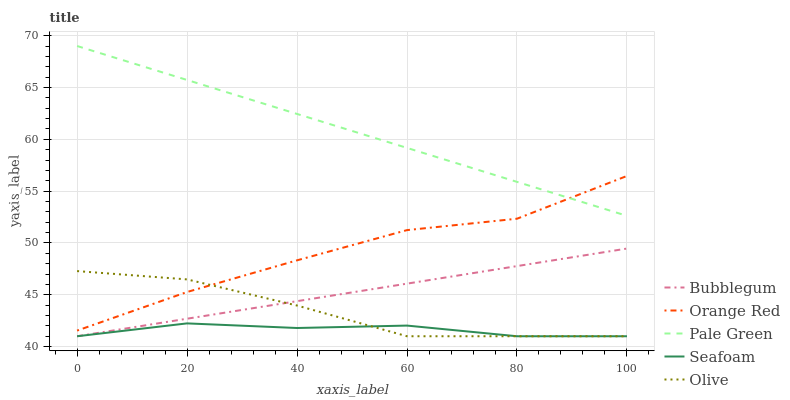Does Seafoam have the minimum area under the curve?
Answer yes or no. Yes. Does Pale Green have the maximum area under the curve?
Answer yes or no. Yes. Does Orange Red have the minimum area under the curve?
Answer yes or no. No. Does Orange Red have the maximum area under the curve?
Answer yes or no. No. Is Bubblegum the smoothest?
Answer yes or no. Yes. Is Orange Red the roughest?
Answer yes or no. Yes. Is Pale Green the smoothest?
Answer yes or no. No. Is Pale Green the roughest?
Answer yes or no. No. Does Olive have the lowest value?
Answer yes or no. Yes. Does Orange Red have the lowest value?
Answer yes or no. No. Does Pale Green have the highest value?
Answer yes or no. Yes. Does Orange Red have the highest value?
Answer yes or no. No. Is Seafoam less than Orange Red?
Answer yes or no. Yes. Is Orange Red greater than Bubblegum?
Answer yes or no. Yes. Does Bubblegum intersect Seafoam?
Answer yes or no. Yes. Is Bubblegum less than Seafoam?
Answer yes or no. No. Is Bubblegum greater than Seafoam?
Answer yes or no. No. Does Seafoam intersect Orange Red?
Answer yes or no. No. 